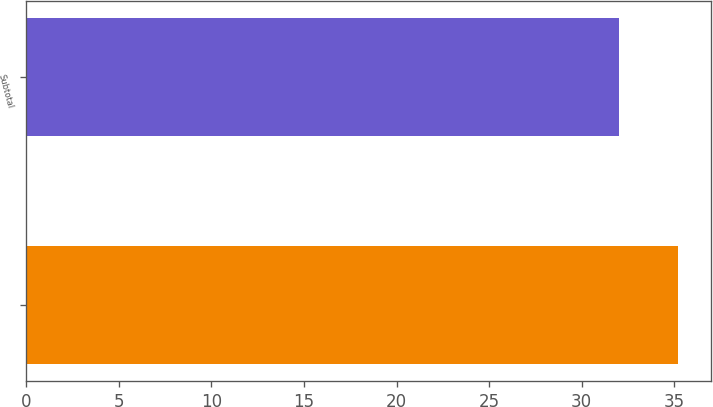<chart> <loc_0><loc_0><loc_500><loc_500><bar_chart><ecel><fcel>Subtotal<nl><fcel>35.2<fcel>32<nl></chart> 